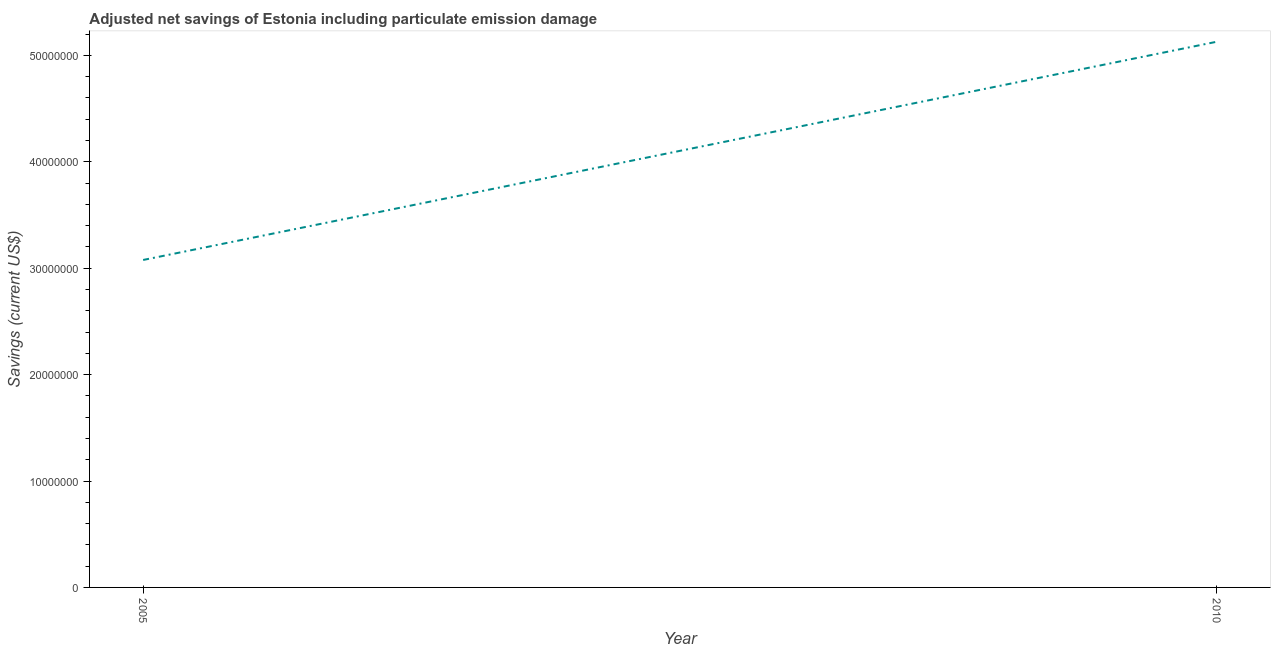What is the adjusted net savings in 2005?
Keep it short and to the point. 3.08e+07. Across all years, what is the maximum adjusted net savings?
Offer a terse response. 5.13e+07. Across all years, what is the minimum adjusted net savings?
Provide a short and direct response. 3.08e+07. What is the sum of the adjusted net savings?
Your answer should be compact. 8.20e+07. What is the difference between the adjusted net savings in 2005 and 2010?
Keep it short and to the point. -2.05e+07. What is the average adjusted net savings per year?
Ensure brevity in your answer.  4.10e+07. What is the median adjusted net savings?
Make the answer very short. 4.10e+07. Do a majority of the years between 2010 and 2005 (inclusive) have adjusted net savings greater than 44000000 US$?
Offer a terse response. No. What is the ratio of the adjusted net savings in 2005 to that in 2010?
Give a very brief answer. 0.6. In how many years, is the adjusted net savings greater than the average adjusted net savings taken over all years?
Make the answer very short. 1. How many lines are there?
Provide a succinct answer. 1. What is the difference between two consecutive major ticks on the Y-axis?
Provide a short and direct response. 1.00e+07. Does the graph contain any zero values?
Your answer should be very brief. No. What is the title of the graph?
Your response must be concise. Adjusted net savings of Estonia including particulate emission damage. What is the label or title of the Y-axis?
Offer a very short reply. Savings (current US$). What is the Savings (current US$) in 2005?
Offer a terse response. 3.08e+07. What is the Savings (current US$) in 2010?
Provide a succinct answer. 5.13e+07. What is the difference between the Savings (current US$) in 2005 and 2010?
Offer a terse response. -2.05e+07. What is the ratio of the Savings (current US$) in 2005 to that in 2010?
Keep it short and to the point. 0.6. 